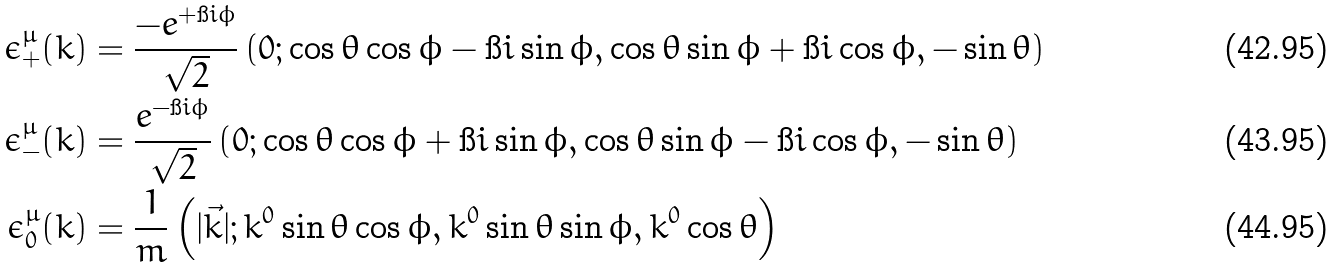Convert formula to latex. <formula><loc_0><loc_0><loc_500><loc_500>\epsilon ^ { \mu } _ { + } ( k ) & = \frac { - e ^ { + \i i \phi } } { \sqrt { 2 } } \left ( 0 ; \cos \theta \cos \phi - \i i \sin \phi , \cos \theta \sin \phi + \i i \cos \phi , - \sin \theta \right ) \\ \epsilon ^ { \mu } _ { - } ( k ) & = \frac { e ^ { - \i i \phi } } { \sqrt { 2 } } \left ( 0 ; \cos \theta \cos \phi + \i i \sin \phi , \cos \theta \sin \phi - \i i \cos \phi , - \sin \theta \right ) \\ \epsilon ^ { \mu } _ { 0 } ( k ) & = \frac { 1 } { m } \left ( | \vec { k } | ; k ^ { 0 } \sin \theta \cos \phi , k ^ { 0 } \sin \theta \sin \phi , k ^ { 0 } \cos \theta \right )</formula> 